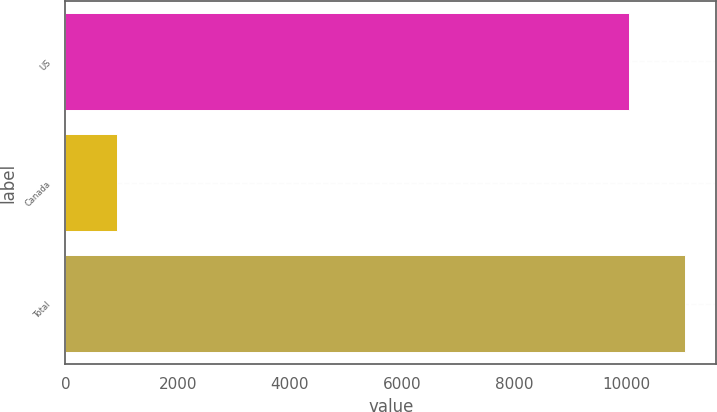<chart> <loc_0><loc_0><loc_500><loc_500><bar_chart><fcel>US<fcel>Canada<fcel>Total<nl><fcel>10040<fcel>910<fcel>11044<nl></chart> 